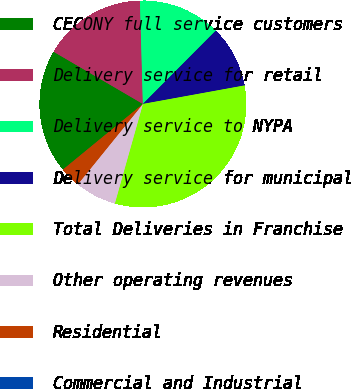Convert chart. <chart><loc_0><loc_0><loc_500><loc_500><pie_chart><fcel>CECONY full service customers<fcel>Delivery service for retail<fcel>Delivery service to NYPA<fcel>Delivery service for municipal<fcel>Total Deliveries in Franchise<fcel>Other operating revenues<fcel>Residential<fcel>Commercial and Industrial<nl><fcel>19.35%<fcel>16.13%<fcel>12.9%<fcel>9.68%<fcel>32.24%<fcel>6.46%<fcel>3.23%<fcel>0.01%<nl></chart> 